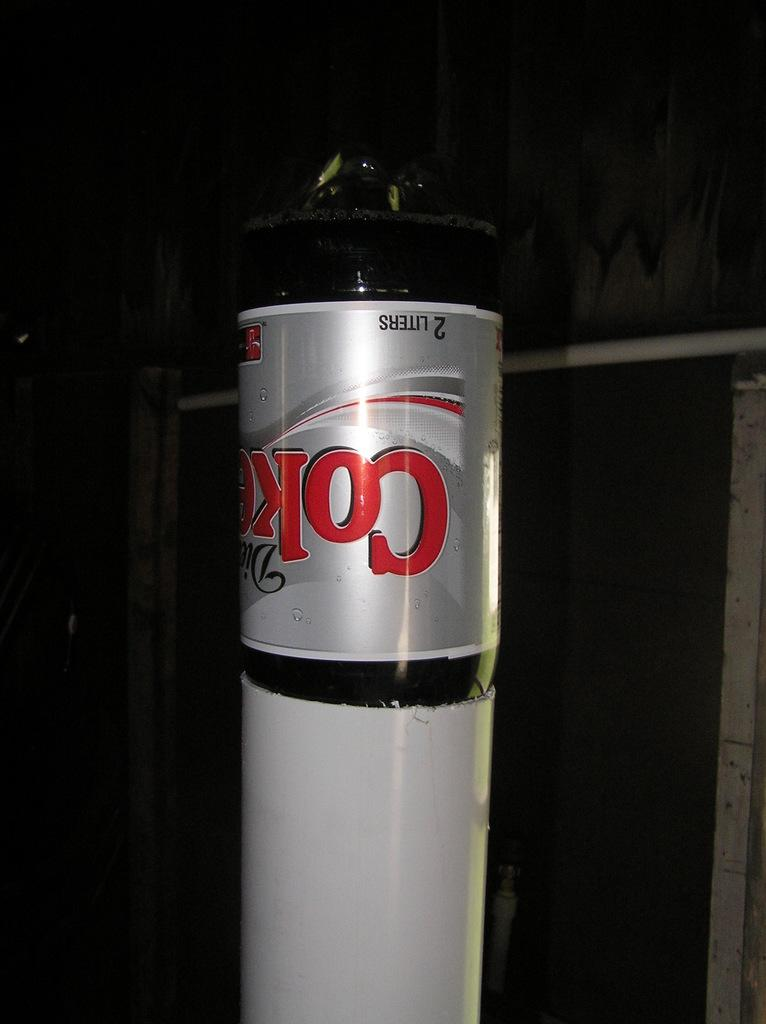<image>
Present a compact description of the photo's key features. 2 Liter Diet Coke bottle set upside down in side of a large cut off section of PVC pipe which fits up to 1/5 of the way down the bottle. 